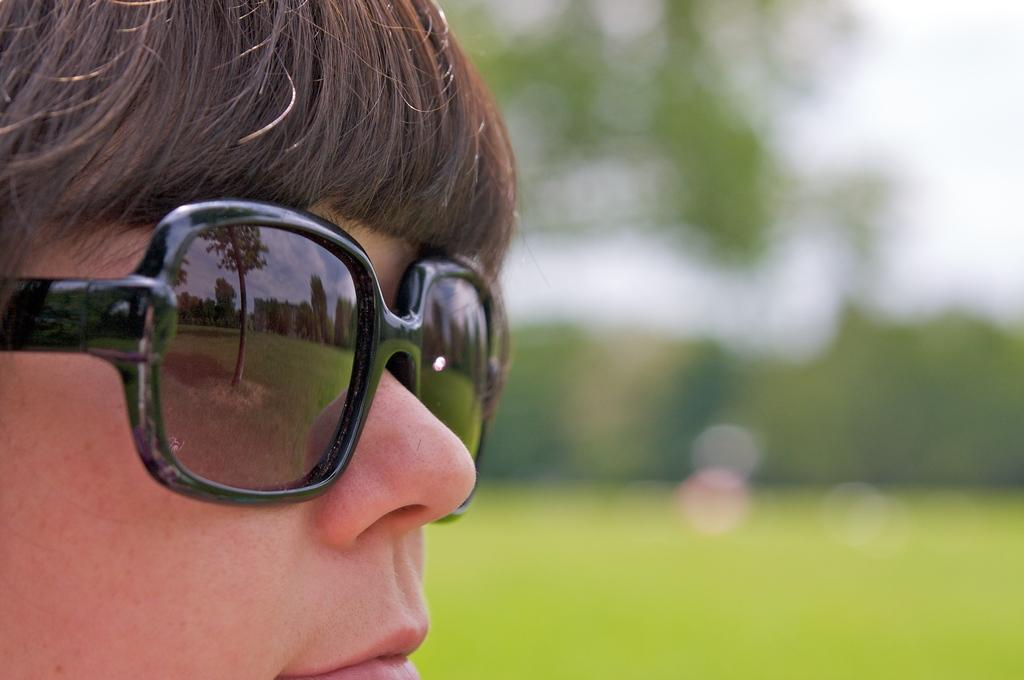What is the main subject of the image? There is a person in the image. What is the person wearing in the image? The person is wearing goggles. What type of apples can be seen cooking in the oven in the image? There is no oven or apples present in the image; it only features a person wearing goggles. 